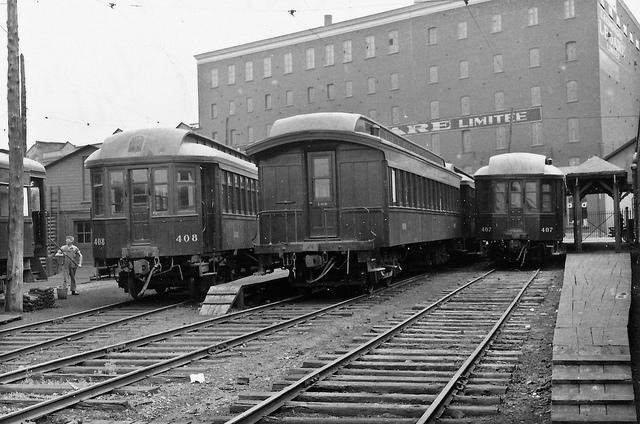Is the train moving?
Give a very brief answer. No. Where is the middle one?
Give a very brief answer. In middle. How many trains are on the track?
Write a very short answer. 3. What color is the train?
Concise answer only. Gray. How many trains are there?
Give a very brief answer. 3. How is this train powered?
Short answer required. Engine. What is the first number in the sequence of numbers on the first train on the left?
Be succinct. 4. Is this a recent photo?
Concise answer only. No. How many windows are visible on the building?
Write a very short answer. 25. Is the train leaving the station?
Concise answer only. No. How many buildings are in the background?
Write a very short answer. 1. 